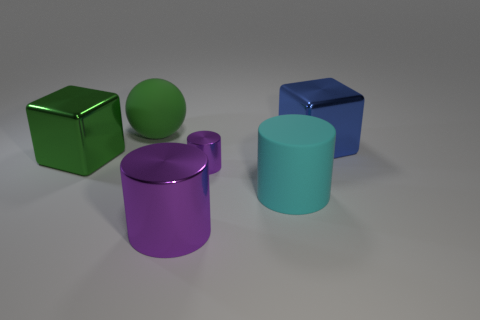What is the size of the metallic cylinder on the right side of the big purple metal thing?
Ensure brevity in your answer.  Small. Does the small object have the same color as the large metal cylinder?
Your answer should be compact. Yes. There is a big thing that is both in front of the blue metallic cube and behind the cyan rubber cylinder; what is its color?
Make the answer very short. Green. How many large purple metal things are in front of the matte thing on the right side of the green sphere?
Your answer should be compact. 1. The green thing that is the same material as the cyan cylinder is what size?
Give a very brief answer. Large. Is the tiny object made of the same material as the big green ball?
Ensure brevity in your answer.  No. What number of blocks are either green rubber things or rubber things?
Make the answer very short. 0. What color is the cylinder on the right side of the purple thing behind the cyan object?
Your answer should be very brief. Cyan. The other metal thing that is the same color as the small shiny object is what size?
Offer a very short reply. Large. How many blue metallic blocks are behind the big cube to the right of the metal block that is on the left side of the big metallic cylinder?
Your answer should be compact. 0. 